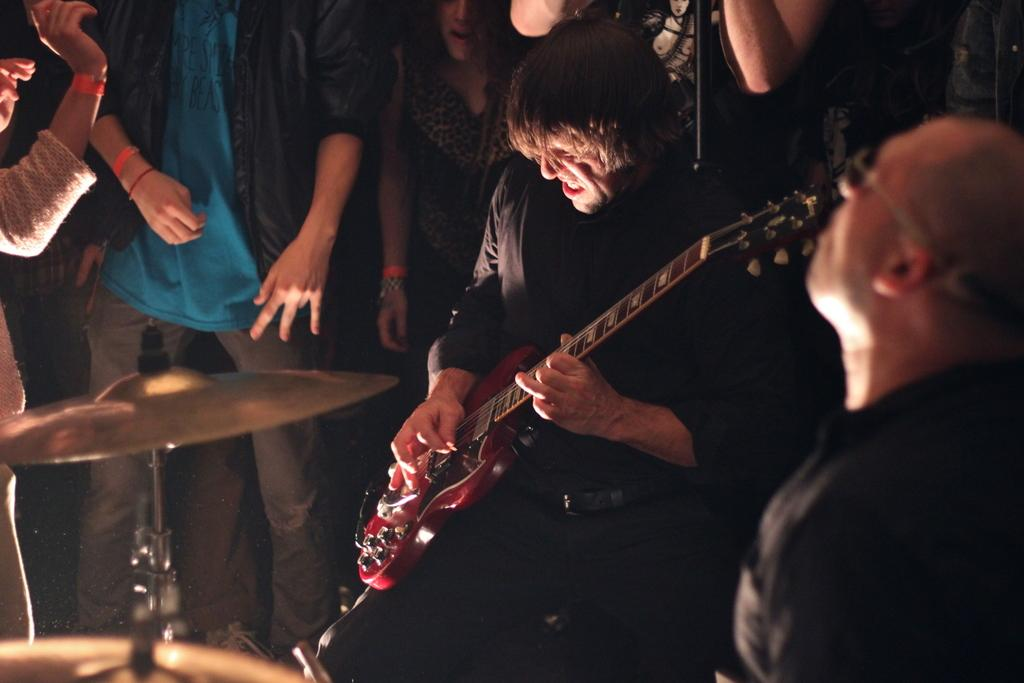How many people are in the image? There is a group of persons in the image. What are the people in the group doing? One person in the group is playing a musical instrument, while the other persons are standing around the person playing the musical instrument. Can you see any planes in the image? There are no planes visible in the image. Is there a stranger in the group of persons? The facts provided do not mention any strangers, so we cannot determine if there is a stranger in the group. 